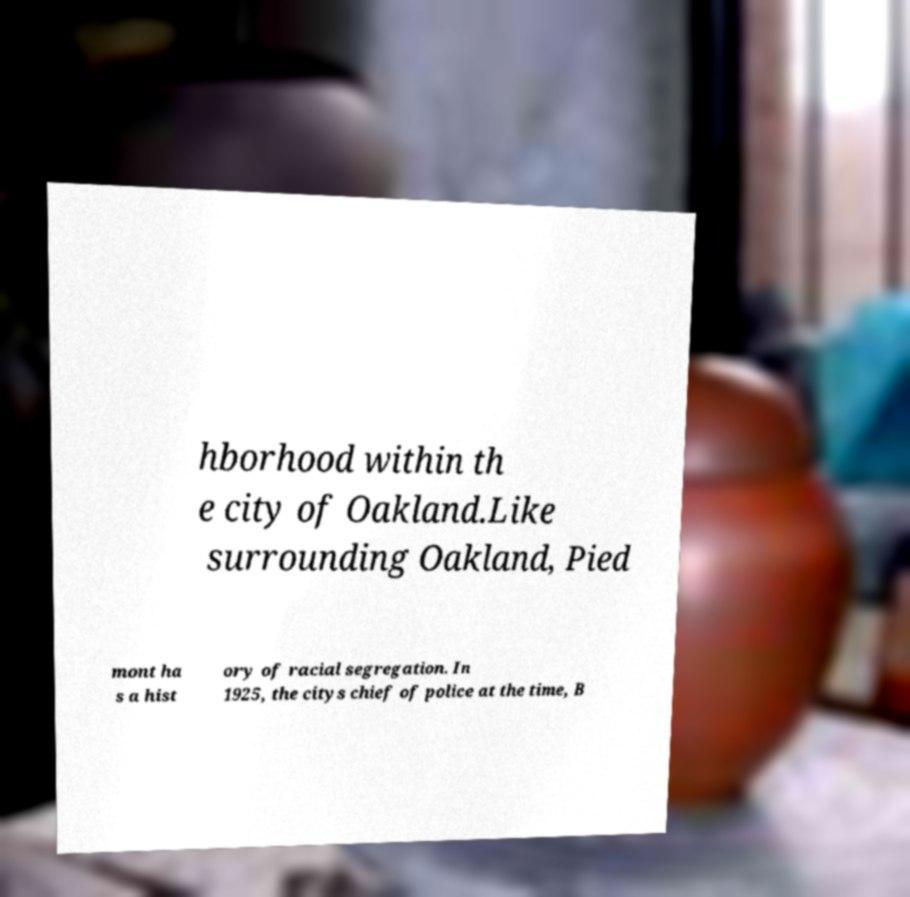Can you read and provide the text displayed in the image?This photo seems to have some interesting text. Can you extract and type it out for me? hborhood within th e city of Oakland.Like surrounding Oakland, Pied mont ha s a hist ory of racial segregation. In 1925, the citys chief of police at the time, B 